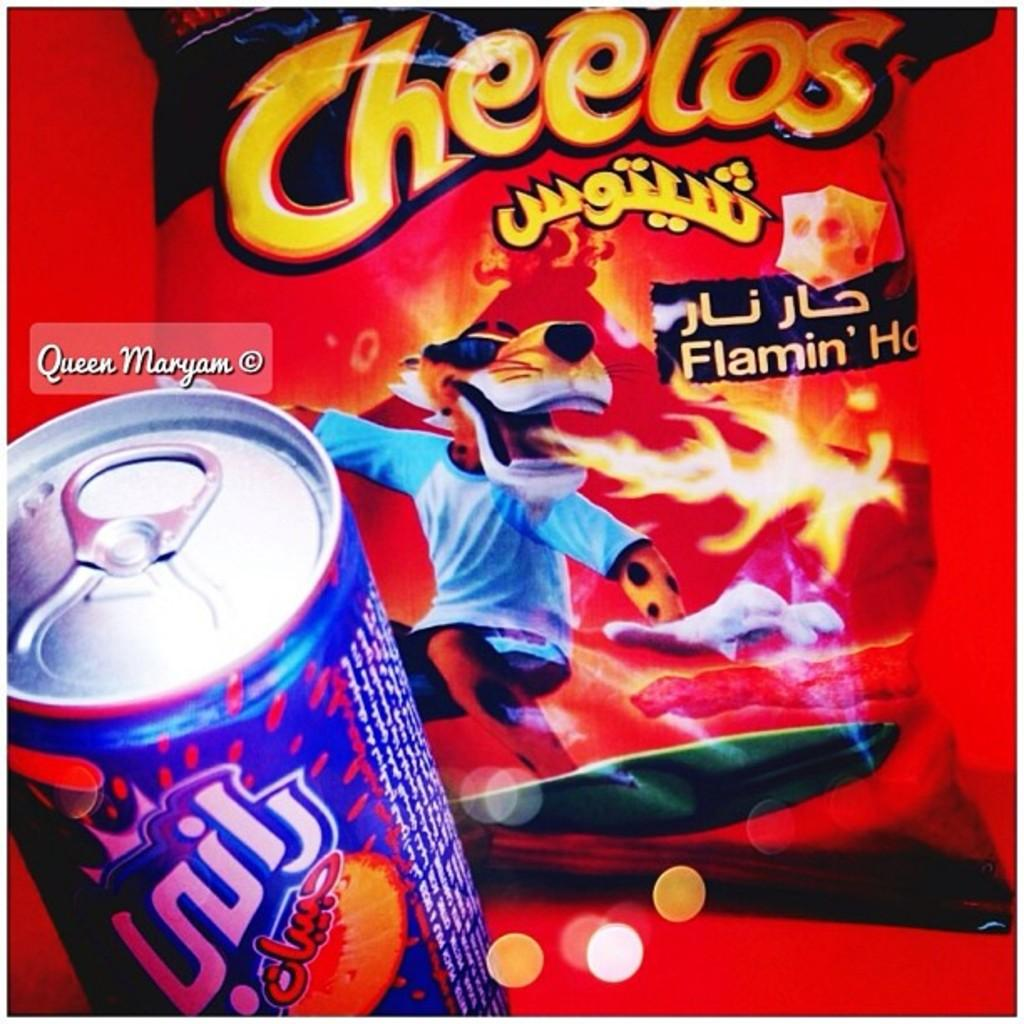Provide a one-sentence caption for the provided image. A soda and a bag of Flaming Hot Cheetos. 